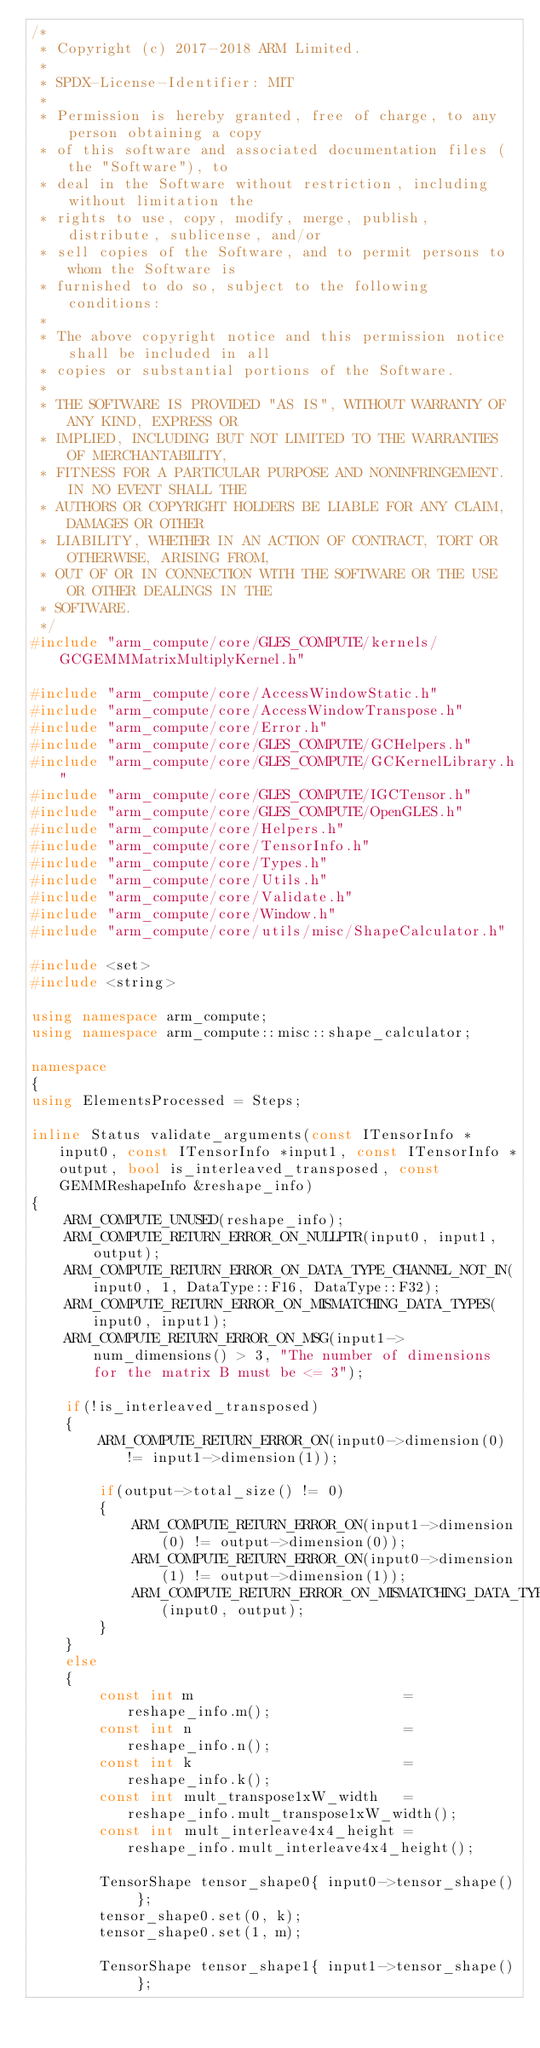<code> <loc_0><loc_0><loc_500><loc_500><_C++_>/*
 * Copyright (c) 2017-2018 ARM Limited.
 *
 * SPDX-License-Identifier: MIT
 *
 * Permission is hereby granted, free of charge, to any person obtaining a copy
 * of this software and associated documentation files (the "Software"), to
 * deal in the Software without restriction, including without limitation the
 * rights to use, copy, modify, merge, publish, distribute, sublicense, and/or
 * sell copies of the Software, and to permit persons to whom the Software is
 * furnished to do so, subject to the following conditions:
 *
 * The above copyright notice and this permission notice shall be included in all
 * copies or substantial portions of the Software.
 *
 * THE SOFTWARE IS PROVIDED "AS IS", WITHOUT WARRANTY OF ANY KIND, EXPRESS OR
 * IMPLIED, INCLUDING BUT NOT LIMITED TO THE WARRANTIES OF MERCHANTABILITY,
 * FITNESS FOR A PARTICULAR PURPOSE AND NONINFRINGEMENT. IN NO EVENT SHALL THE
 * AUTHORS OR COPYRIGHT HOLDERS BE LIABLE FOR ANY CLAIM, DAMAGES OR OTHER
 * LIABILITY, WHETHER IN AN ACTION OF CONTRACT, TORT OR OTHERWISE, ARISING FROM,
 * OUT OF OR IN CONNECTION WITH THE SOFTWARE OR THE USE OR OTHER DEALINGS IN THE
 * SOFTWARE.
 */
#include "arm_compute/core/GLES_COMPUTE/kernels/GCGEMMMatrixMultiplyKernel.h"

#include "arm_compute/core/AccessWindowStatic.h"
#include "arm_compute/core/AccessWindowTranspose.h"
#include "arm_compute/core/Error.h"
#include "arm_compute/core/GLES_COMPUTE/GCHelpers.h"
#include "arm_compute/core/GLES_COMPUTE/GCKernelLibrary.h"
#include "arm_compute/core/GLES_COMPUTE/IGCTensor.h"
#include "arm_compute/core/GLES_COMPUTE/OpenGLES.h"
#include "arm_compute/core/Helpers.h"
#include "arm_compute/core/TensorInfo.h"
#include "arm_compute/core/Types.h"
#include "arm_compute/core/Utils.h"
#include "arm_compute/core/Validate.h"
#include "arm_compute/core/Window.h"
#include "arm_compute/core/utils/misc/ShapeCalculator.h"

#include <set>
#include <string>

using namespace arm_compute;
using namespace arm_compute::misc::shape_calculator;

namespace
{
using ElementsProcessed = Steps;

inline Status validate_arguments(const ITensorInfo *input0, const ITensorInfo *input1, const ITensorInfo *output, bool is_interleaved_transposed, const GEMMReshapeInfo &reshape_info)
{
    ARM_COMPUTE_UNUSED(reshape_info);
    ARM_COMPUTE_RETURN_ERROR_ON_NULLPTR(input0, input1, output);
    ARM_COMPUTE_RETURN_ERROR_ON_DATA_TYPE_CHANNEL_NOT_IN(input0, 1, DataType::F16, DataType::F32);
    ARM_COMPUTE_RETURN_ERROR_ON_MISMATCHING_DATA_TYPES(input0, input1);
    ARM_COMPUTE_RETURN_ERROR_ON_MSG(input1->num_dimensions() > 3, "The number of dimensions for the matrix B must be <= 3");

    if(!is_interleaved_transposed)
    {
        ARM_COMPUTE_RETURN_ERROR_ON(input0->dimension(0) != input1->dimension(1));

        if(output->total_size() != 0)
        {
            ARM_COMPUTE_RETURN_ERROR_ON(input1->dimension(0) != output->dimension(0));
            ARM_COMPUTE_RETURN_ERROR_ON(input0->dimension(1) != output->dimension(1));
            ARM_COMPUTE_RETURN_ERROR_ON_MISMATCHING_DATA_TYPES(input0, output);
        }
    }
    else
    {
        const int m                         = reshape_info.m();
        const int n                         = reshape_info.n();
        const int k                         = reshape_info.k();
        const int mult_transpose1xW_width   = reshape_info.mult_transpose1xW_width();
        const int mult_interleave4x4_height = reshape_info.mult_interleave4x4_height();

        TensorShape tensor_shape0{ input0->tensor_shape() };
        tensor_shape0.set(0, k);
        tensor_shape0.set(1, m);

        TensorShape tensor_shape1{ input1->tensor_shape() };</code> 